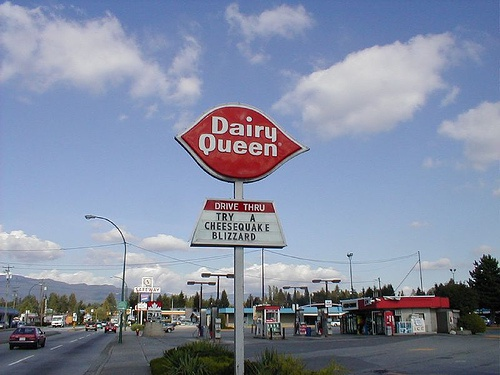Describe the objects in this image and their specific colors. I can see car in gray, black, and purple tones, car in gray, black, and darkgray tones, car in gray, black, darkgray, and maroon tones, car in gray, black, maroon, and brown tones, and car in gray, black, and navy tones in this image. 